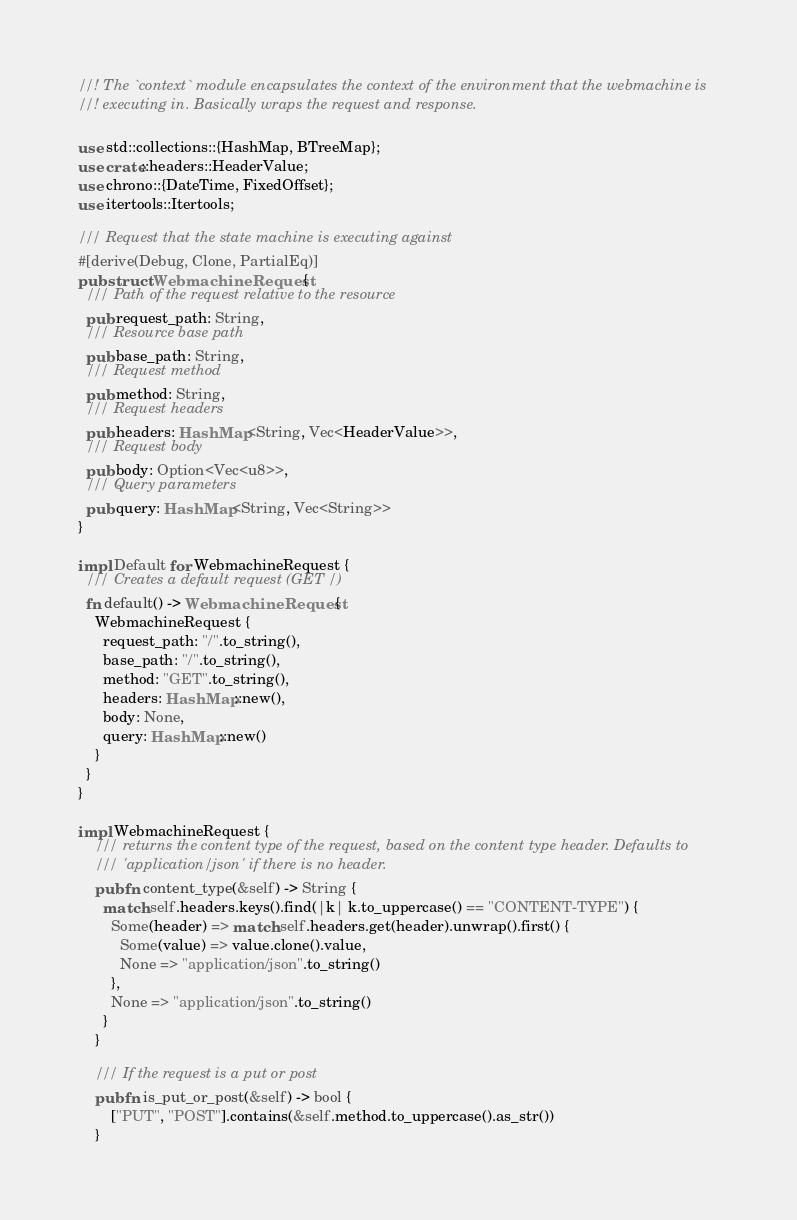<code> <loc_0><loc_0><loc_500><loc_500><_Rust_>//! The `context` module encapsulates the context of the environment that the webmachine is
//! executing in. Basically wraps the request and response.

use std::collections::{HashMap, BTreeMap};
use crate::headers::HeaderValue;
use chrono::{DateTime, FixedOffset};
use itertools::Itertools;

/// Request that the state machine is executing against
#[derive(Debug, Clone, PartialEq)]
pub struct WebmachineRequest {
  /// Path of the request relative to the resource
  pub request_path: String,
  /// Resource base path
  pub base_path: String,
  /// Request method
  pub method: String,
  /// Request headers
  pub headers: HashMap<String, Vec<HeaderValue>>,
  /// Request body
  pub body: Option<Vec<u8>>,
  /// Query parameters
  pub query: HashMap<String, Vec<String>>
}

impl Default for WebmachineRequest {
  /// Creates a default request (GET /)
  fn default() -> WebmachineRequest {
    WebmachineRequest {
      request_path: "/".to_string(),
      base_path: "/".to_string(),
      method: "GET".to_string(),
      headers: HashMap::new(),
      body: None,
      query: HashMap::new()
    }
  }
}

impl WebmachineRequest {
    /// returns the content type of the request, based on the content type header. Defaults to
    /// 'application/json' if there is no header.
    pub fn content_type(&self) -> String {
      match self.headers.keys().find(|k| k.to_uppercase() == "CONTENT-TYPE") {
        Some(header) => match self.headers.get(header).unwrap().first() {
          Some(value) => value.clone().value,
          None => "application/json".to_string()
        },
        None => "application/json".to_string()
      }
    }

    /// If the request is a put or post
    pub fn is_put_or_post(&self) -> bool {
        ["PUT", "POST"].contains(&self.method.to_uppercase().as_str())
    }
</code> 